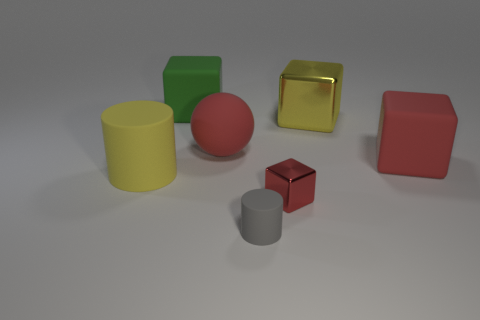Subtract 2 cubes. How many cubes are left? 2 Subtract all green cubes. How many cubes are left? 3 Subtract all cyan blocks. Subtract all cyan spheres. How many blocks are left? 4 Add 1 big blocks. How many objects exist? 8 Subtract all cylinders. How many objects are left? 5 Add 6 big yellow cylinders. How many big yellow cylinders exist? 7 Subtract 0 gray blocks. How many objects are left? 7 Subtract all big red rubber cubes. Subtract all big red rubber things. How many objects are left? 4 Add 2 tiny red metal objects. How many tiny red metal objects are left? 3 